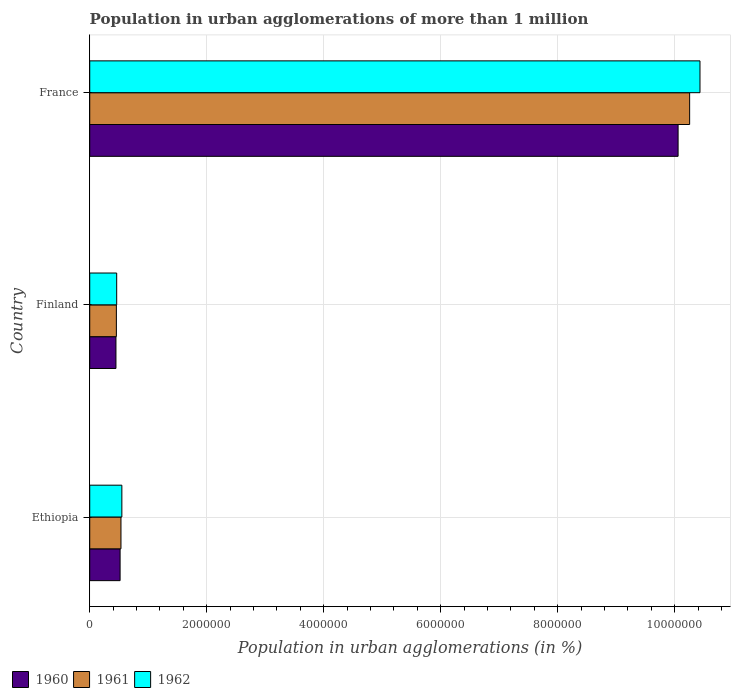Are the number of bars per tick equal to the number of legend labels?
Your answer should be very brief. Yes. What is the label of the 2nd group of bars from the top?
Offer a very short reply. Finland. In how many cases, is the number of bars for a given country not equal to the number of legend labels?
Make the answer very short. 0. What is the population in urban agglomerations in 1961 in Ethiopia?
Offer a very short reply. 5.34e+05. Across all countries, what is the maximum population in urban agglomerations in 1961?
Your response must be concise. 1.03e+07. Across all countries, what is the minimum population in urban agglomerations in 1960?
Provide a short and direct response. 4.48e+05. In which country was the population in urban agglomerations in 1960 maximum?
Offer a terse response. France. What is the total population in urban agglomerations in 1962 in the graph?
Offer a terse response. 1.14e+07. What is the difference between the population in urban agglomerations in 1960 in Ethiopia and that in Finland?
Make the answer very short. 7.10e+04. What is the difference between the population in urban agglomerations in 1960 in Ethiopia and the population in urban agglomerations in 1961 in France?
Provide a short and direct response. -9.74e+06. What is the average population in urban agglomerations in 1962 per country?
Give a very brief answer. 3.81e+06. What is the difference between the population in urban agglomerations in 1962 and population in urban agglomerations in 1961 in Ethiopia?
Keep it short and to the point. 1.52e+04. In how many countries, is the population in urban agglomerations in 1961 greater than 9200000 %?
Offer a very short reply. 1. What is the ratio of the population in urban agglomerations in 1960 in Ethiopia to that in Finland?
Offer a terse response. 1.16. What is the difference between the highest and the second highest population in urban agglomerations in 1960?
Provide a succinct answer. 9.54e+06. What is the difference between the highest and the lowest population in urban agglomerations in 1962?
Offer a terse response. 9.97e+06. In how many countries, is the population in urban agglomerations in 1962 greater than the average population in urban agglomerations in 1962 taken over all countries?
Ensure brevity in your answer.  1. Is the sum of the population in urban agglomerations in 1962 in Ethiopia and France greater than the maximum population in urban agglomerations in 1960 across all countries?
Keep it short and to the point. Yes. What does the 2nd bar from the top in Ethiopia represents?
Provide a short and direct response. 1961. What does the 2nd bar from the bottom in Finland represents?
Provide a short and direct response. 1961. How many bars are there?
Your response must be concise. 9. Are all the bars in the graph horizontal?
Your response must be concise. Yes. How many countries are there in the graph?
Give a very brief answer. 3. What is the difference between two consecutive major ticks on the X-axis?
Provide a succinct answer. 2.00e+06. Does the graph contain any zero values?
Make the answer very short. No. How many legend labels are there?
Provide a short and direct response. 3. How are the legend labels stacked?
Provide a succinct answer. Horizontal. What is the title of the graph?
Offer a very short reply. Population in urban agglomerations of more than 1 million. Does "1979" appear as one of the legend labels in the graph?
Your answer should be compact. No. What is the label or title of the X-axis?
Ensure brevity in your answer.  Population in urban agglomerations (in %). What is the Population in urban agglomerations (in %) in 1960 in Ethiopia?
Ensure brevity in your answer.  5.19e+05. What is the Population in urban agglomerations (in %) in 1961 in Ethiopia?
Ensure brevity in your answer.  5.34e+05. What is the Population in urban agglomerations (in %) in 1962 in Ethiopia?
Provide a short and direct response. 5.49e+05. What is the Population in urban agglomerations (in %) in 1960 in Finland?
Ensure brevity in your answer.  4.48e+05. What is the Population in urban agglomerations (in %) of 1961 in Finland?
Your answer should be very brief. 4.55e+05. What is the Population in urban agglomerations (in %) of 1962 in Finland?
Your answer should be compact. 4.61e+05. What is the Population in urban agglomerations (in %) in 1960 in France?
Make the answer very short. 1.01e+07. What is the Population in urban agglomerations (in %) of 1961 in France?
Your answer should be very brief. 1.03e+07. What is the Population in urban agglomerations (in %) in 1962 in France?
Your answer should be very brief. 1.04e+07. Across all countries, what is the maximum Population in urban agglomerations (in %) of 1960?
Ensure brevity in your answer.  1.01e+07. Across all countries, what is the maximum Population in urban agglomerations (in %) of 1961?
Make the answer very short. 1.03e+07. Across all countries, what is the maximum Population in urban agglomerations (in %) of 1962?
Your answer should be very brief. 1.04e+07. Across all countries, what is the minimum Population in urban agglomerations (in %) in 1960?
Provide a succinct answer. 4.48e+05. Across all countries, what is the minimum Population in urban agglomerations (in %) of 1961?
Give a very brief answer. 4.55e+05. Across all countries, what is the minimum Population in urban agglomerations (in %) of 1962?
Ensure brevity in your answer.  4.61e+05. What is the total Population in urban agglomerations (in %) of 1960 in the graph?
Offer a very short reply. 1.10e+07. What is the total Population in urban agglomerations (in %) of 1961 in the graph?
Give a very brief answer. 1.12e+07. What is the total Population in urban agglomerations (in %) in 1962 in the graph?
Offer a terse response. 1.14e+07. What is the difference between the Population in urban agglomerations (in %) of 1960 in Ethiopia and that in Finland?
Your answer should be very brief. 7.10e+04. What is the difference between the Population in urban agglomerations (in %) of 1961 in Ethiopia and that in Finland?
Provide a short and direct response. 7.85e+04. What is the difference between the Population in urban agglomerations (in %) in 1962 in Ethiopia and that in Finland?
Offer a very short reply. 8.82e+04. What is the difference between the Population in urban agglomerations (in %) of 1960 in Ethiopia and that in France?
Your response must be concise. -9.54e+06. What is the difference between the Population in urban agglomerations (in %) in 1961 in Ethiopia and that in France?
Offer a very short reply. -9.72e+06. What is the difference between the Population in urban agglomerations (in %) of 1962 in Ethiopia and that in France?
Offer a terse response. -9.88e+06. What is the difference between the Population in urban agglomerations (in %) in 1960 in Finland and that in France?
Your answer should be compact. -9.61e+06. What is the difference between the Population in urban agglomerations (in %) in 1961 in Finland and that in France?
Offer a very short reply. -9.80e+06. What is the difference between the Population in urban agglomerations (in %) in 1962 in Finland and that in France?
Keep it short and to the point. -9.97e+06. What is the difference between the Population in urban agglomerations (in %) of 1960 in Ethiopia and the Population in urban agglomerations (in %) of 1961 in Finland?
Make the answer very short. 6.37e+04. What is the difference between the Population in urban agglomerations (in %) in 1960 in Ethiopia and the Population in urban agglomerations (in %) in 1962 in Finland?
Offer a very short reply. 5.82e+04. What is the difference between the Population in urban agglomerations (in %) in 1961 in Ethiopia and the Population in urban agglomerations (in %) in 1962 in Finland?
Give a very brief answer. 7.30e+04. What is the difference between the Population in urban agglomerations (in %) in 1960 in Ethiopia and the Population in urban agglomerations (in %) in 1961 in France?
Make the answer very short. -9.74e+06. What is the difference between the Population in urban agglomerations (in %) of 1960 in Ethiopia and the Population in urban agglomerations (in %) of 1962 in France?
Keep it short and to the point. -9.91e+06. What is the difference between the Population in urban agglomerations (in %) in 1961 in Ethiopia and the Population in urban agglomerations (in %) in 1962 in France?
Your answer should be compact. -9.90e+06. What is the difference between the Population in urban agglomerations (in %) of 1960 in Finland and the Population in urban agglomerations (in %) of 1961 in France?
Provide a succinct answer. -9.81e+06. What is the difference between the Population in urban agglomerations (in %) in 1960 in Finland and the Population in urban agglomerations (in %) in 1962 in France?
Make the answer very short. -9.98e+06. What is the difference between the Population in urban agglomerations (in %) of 1961 in Finland and the Population in urban agglomerations (in %) of 1962 in France?
Provide a short and direct response. -9.98e+06. What is the average Population in urban agglomerations (in %) in 1960 per country?
Provide a succinct answer. 3.68e+06. What is the average Population in urban agglomerations (in %) of 1961 per country?
Make the answer very short. 3.75e+06. What is the average Population in urban agglomerations (in %) of 1962 per country?
Your response must be concise. 3.81e+06. What is the difference between the Population in urban agglomerations (in %) of 1960 and Population in urban agglomerations (in %) of 1961 in Ethiopia?
Your answer should be very brief. -1.48e+04. What is the difference between the Population in urban agglomerations (in %) in 1960 and Population in urban agglomerations (in %) in 1962 in Ethiopia?
Your answer should be compact. -3.00e+04. What is the difference between the Population in urban agglomerations (in %) in 1961 and Population in urban agglomerations (in %) in 1962 in Ethiopia?
Your answer should be compact. -1.52e+04. What is the difference between the Population in urban agglomerations (in %) in 1960 and Population in urban agglomerations (in %) in 1961 in Finland?
Make the answer very short. -7296. What is the difference between the Population in urban agglomerations (in %) of 1960 and Population in urban agglomerations (in %) of 1962 in Finland?
Make the answer very short. -1.28e+04. What is the difference between the Population in urban agglomerations (in %) of 1961 and Population in urban agglomerations (in %) of 1962 in Finland?
Offer a very short reply. -5485. What is the difference between the Population in urban agglomerations (in %) in 1960 and Population in urban agglomerations (in %) in 1961 in France?
Make the answer very short. -1.97e+05. What is the difference between the Population in urban agglomerations (in %) in 1960 and Population in urban agglomerations (in %) in 1962 in France?
Offer a very short reply. -3.74e+05. What is the difference between the Population in urban agglomerations (in %) of 1961 and Population in urban agglomerations (in %) of 1962 in France?
Offer a very short reply. -1.77e+05. What is the ratio of the Population in urban agglomerations (in %) of 1960 in Ethiopia to that in Finland?
Your response must be concise. 1.16. What is the ratio of the Population in urban agglomerations (in %) in 1961 in Ethiopia to that in Finland?
Ensure brevity in your answer.  1.17. What is the ratio of the Population in urban agglomerations (in %) in 1962 in Ethiopia to that in Finland?
Ensure brevity in your answer.  1.19. What is the ratio of the Population in urban agglomerations (in %) in 1960 in Ethiopia to that in France?
Provide a succinct answer. 0.05. What is the ratio of the Population in urban agglomerations (in %) in 1961 in Ethiopia to that in France?
Offer a terse response. 0.05. What is the ratio of the Population in urban agglomerations (in %) in 1962 in Ethiopia to that in France?
Give a very brief answer. 0.05. What is the ratio of the Population in urban agglomerations (in %) of 1960 in Finland to that in France?
Offer a terse response. 0.04. What is the ratio of the Population in urban agglomerations (in %) of 1961 in Finland to that in France?
Your answer should be compact. 0.04. What is the ratio of the Population in urban agglomerations (in %) of 1962 in Finland to that in France?
Provide a succinct answer. 0.04. What is the difference between the highest and the second highest Population in urban agglomerations (in %) of 1960?
Make the answer very short. 9.54e+06. What is the difference between the highest and the second highest Population in urban agglomerations (in %) in 1961?
Offer a very short reply. 9.72e+06. What is the difference between the highest and the second highest Population in urban agglomerations (in %) in 1962?
Make the answer very short. 9.88e+06. What is the difference between the highest and the lowest Population in urban agglomerations (in %) of 1960?
Your answer should be compact. 9.61e+06. What is the difference between the highest and the lowest Population in urban agglomerations (in %) of 1961?
Ensure brevity in your answer.  9.80e+06. What is the difference between the highest and the lowest Population in urban agglomerations (in %) in 1962?
Keep it short and to the point. 9.97e+06. 